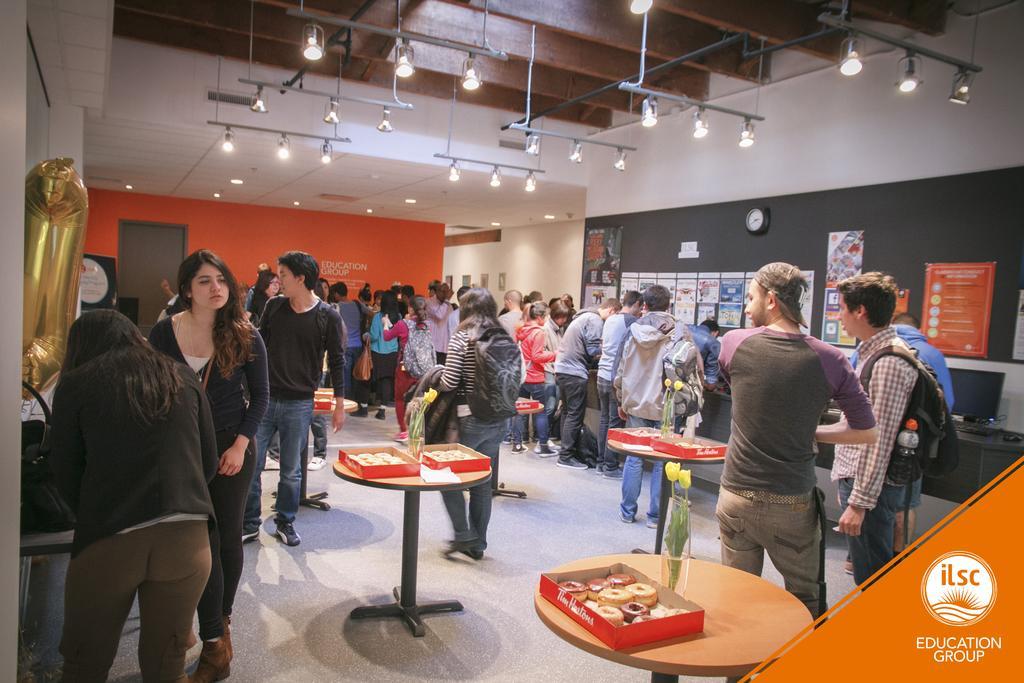How would you summarize this image in a sentence or two? At the top we can see ceiling and lights. Here we can see posts over a board. This is a clock. This is a wall and photo frames over it. We can see all the persons standing on the floor. Here on the table we can see doughnuts in a box and a flower vase. 